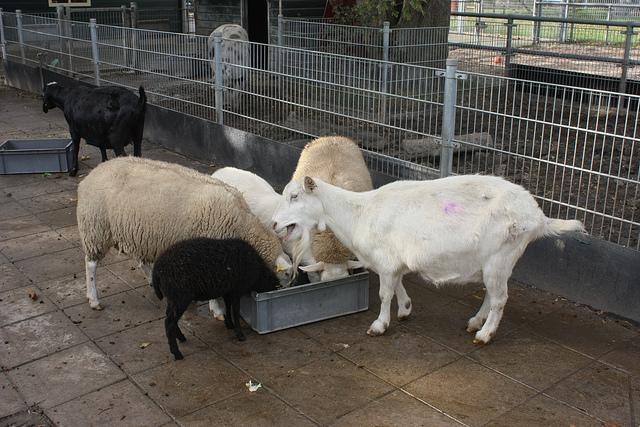Why are the animals crowded around the bucket? Please explain your reasoning. to eat. The animals are snacking. 